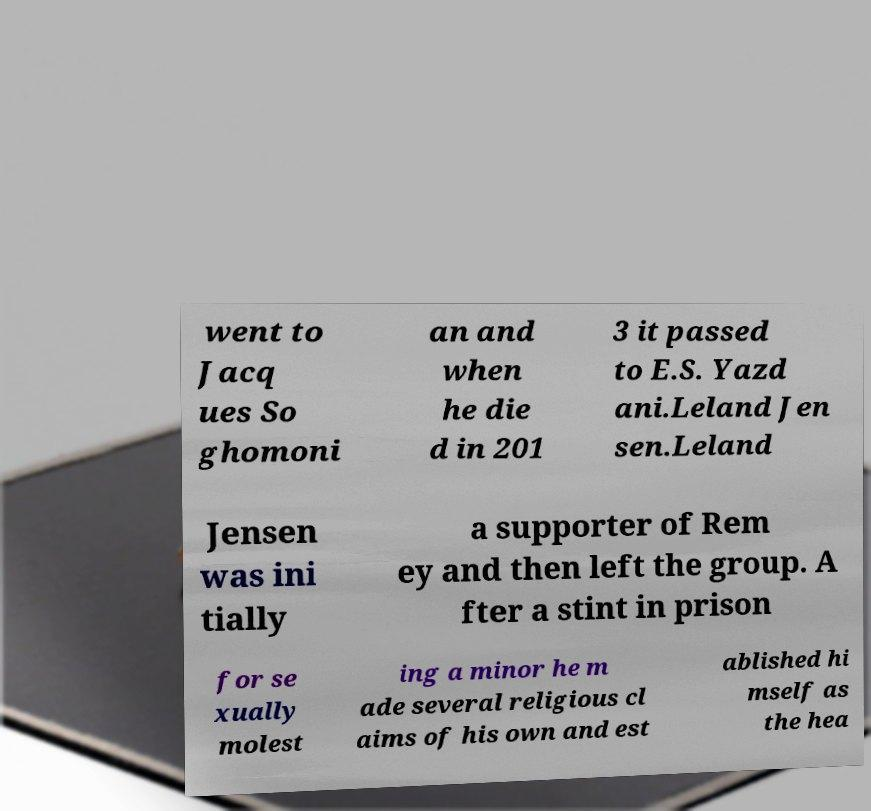For documentation purposes, I need the text within this image transcribed. Could you provide that? went to Jacq ues So ghomoni an and when he die d in 201 3 it passed to E.S. Yazd ani.Leland Jen sen.Leland Jensen was ini tially a supporter of Rem ey and then left the group. A fter a stint in prison for se xually molest ing a minor he m ade several religious cl aims of his own and est ablished hi mself as the hea 